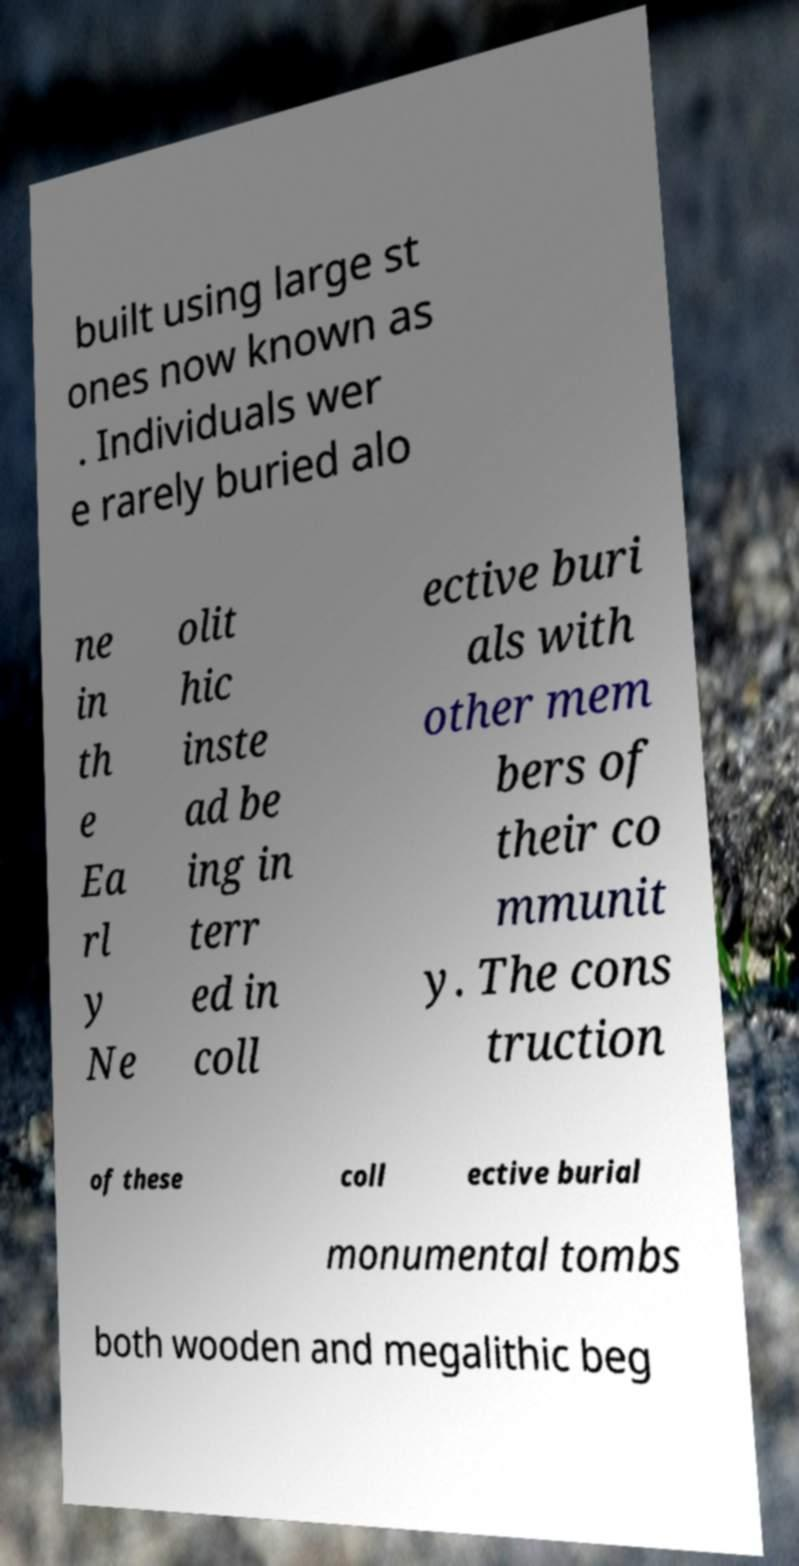I need the written content from this picture converted into text. Can you do that? built using large st ones now known as . Individuals wer e rarely buried alo ne in th e Ea rl y Ne olit hic inste ad be ing in terr ed in coll ective buri als with other mem bers of their co mmunit y. The cons truction of these coll ective burial monumental tombs both wooden and megalithic beg 